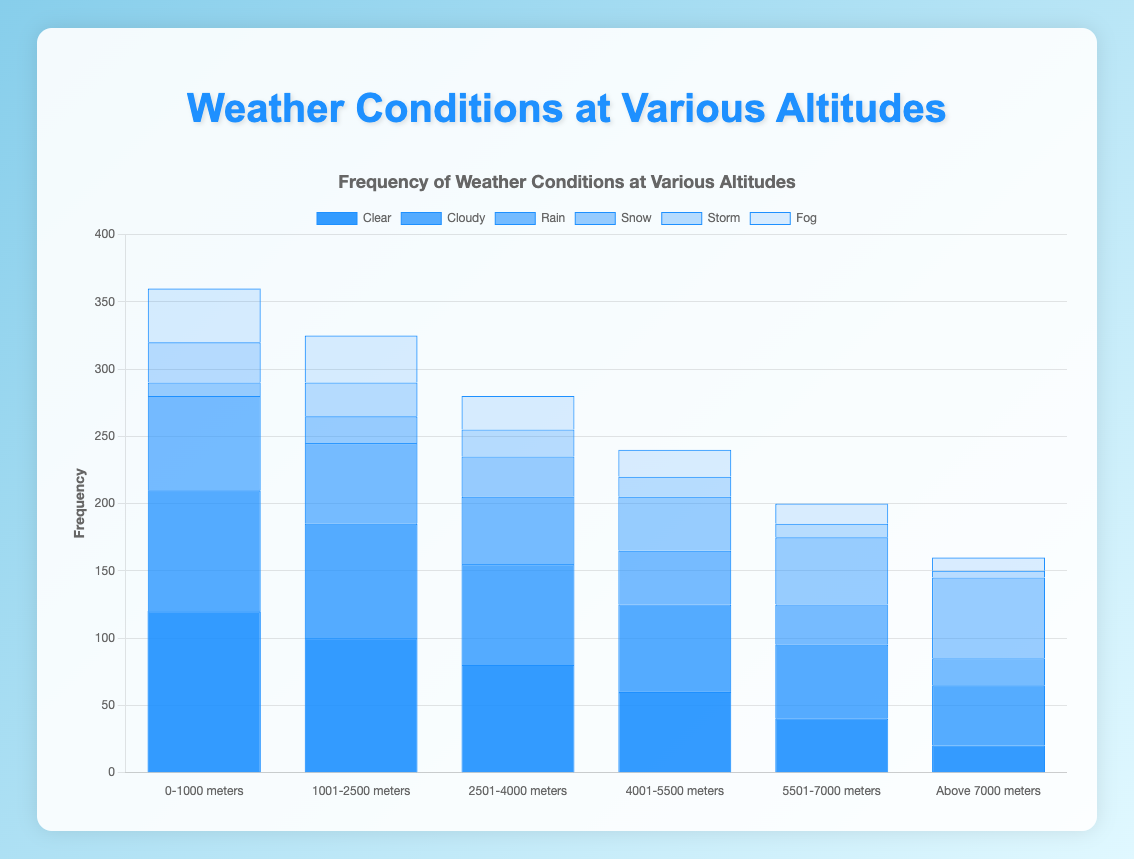Which altitude range has the highest frequency of clear weather conditions? Look at the height of the blue bars representing "Clear" weather conditions and compare them across the altitude ranges. The bar for the "0-1000 meters" range is the highest.
Answer: 0-1000 meters How does the frequency of snowy conditions at 2501-4000 meters compare with that at 5501-7000 meters? Compare the heights of the bars representing "Snow" conditions at 2501-4000 meters and 5501-7000 meters. The bar at 5501-7000 meters is higher.
Answer: Higher at 5501-7000 meters What is the total frequency of foggy conditions across all altitude ranges? Add the frequencies of "Fog" conditions for all altitude ranges: 40 + 35 + 25 + 20 + 15 + 10.
Answer: 145 Which altitude range experiences the least frequency of stormy conditions? Compare the heights of the bars representing "Storm" conditions across all altitude ranges. The bar for "Above 7000 meters" has the least height.
Answer: Above 7000 meters What is the average frequency of clear weather conditions across all altitudes? Add the frequencies of "Clear" conditions: 120 + 100 + 80 + 60 + 40 + 20, then divide by the number of altitude ranges (6): (120 + 100 + 80 + 60 + 40 + 20) / 6.
Answer: 70 Which weather condition has the highest frequency at 4001-5500 meters? Look at the height of the bars at 4001-5500 meters and identify the tallest one; it's for "Clear" conditions.
Answer: Clear Is snow more frequent at higher altitudes? Compare the heights of the "Snow" bar as altitude increases: the bars increase in height until the highest altitude range, showing that snow is more frequent at higher altitudes.
Answer: Yes What is the combined frequency of rainy and stormy conditions at 1001-2500 meters? Add the frequency of "Rain" (60) and "Storm" (25) conditions at 1001-2500 meters: 60 + 25.
Answer: 85 Which condition has the most consistent frequency across all altitude ranges? Observe the variation in heights of the bars for each weather condition across all altitude ranges. "Cloudy" conditions have bars of fairly consistent height.
Answer: Cloudy 